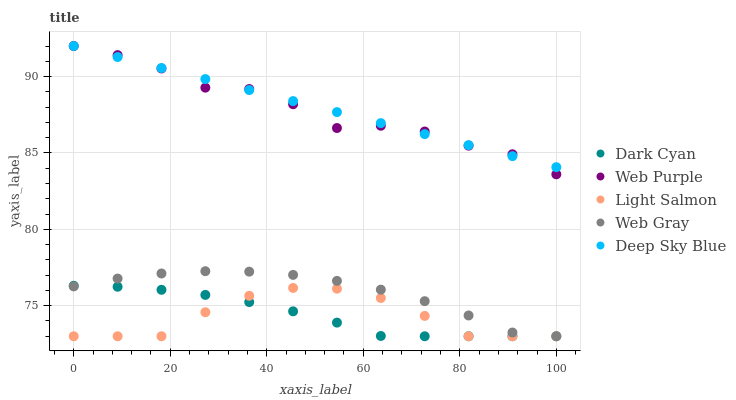Does Light Salmon have the minimum area under the curve?
Answer yes or no. Yes. Does Deep Sky Blue have the maximum area under the curve?
Answer yes or no. Yes. Does Web Purple have the minimum area under the curve?
Answer yes or no. No. Does Web Purple have the maximum area under the curve?
Answer yes or no. No. Is Deep Sky Blue the smoothest?
Answer yes or no. Yes. Is Web Purple the roughest?
Answer yes or no. Yes. Is Web Gray the smoothest?
Answer yes or no. No. Is Web Gray the roughest?
Answer yes or no. No. Does Dark Cyan have the lowest value?
Answer yes or no. Yes. Does Web Purple have the lowest value?
Answer yes or no. No. Does Deep Sky Blue have the highest value?
Answer yes or no. Yes. Does Web Gray have the highest value?
Answer yes or no. No. Is Web Gray less than Deep Sky Blue?
Answer yes or no. Yes. Is Deep Sky Blue greater than Web Gray?
Answer yes or no. Yes. Does Dark Cyan intersect Web Gray?
Answer yes or no. Yes. Is Dark Cyan less than Web Gray?
Answer yes or no. No. Is Dark Cyan greater than Web Gray?
Answer yes or no. No. Does Web Gray intersect Deep Sky Blue?
Answer yes or no. No. 